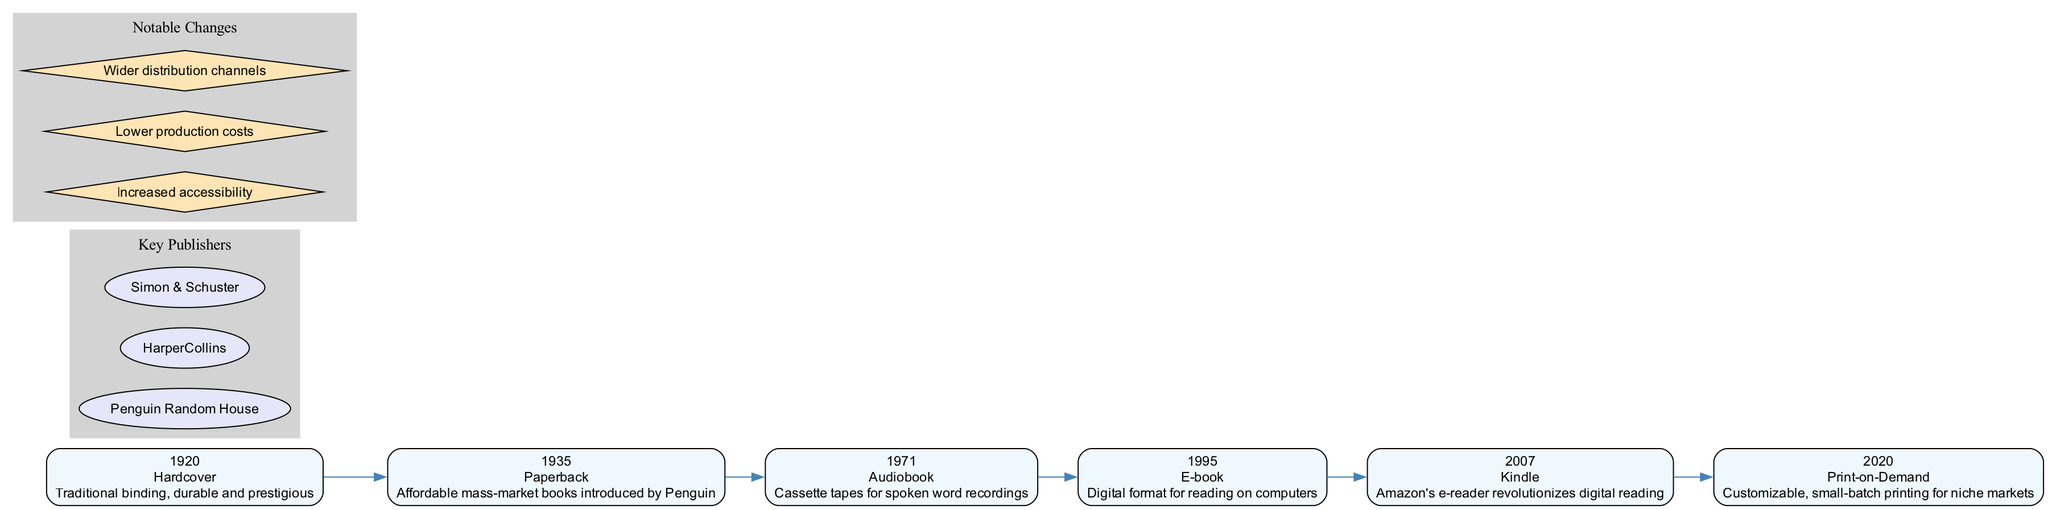What year was the Paperback format introduced? The diagram shows that the Paperback format was introduced in 1935. I can find this by locating the node representing the Paperback format on the timeline.
Answer: 1935 How many book publishing formats are displayed in the timeline? By counting the nodes in the timeline, I see there are six distinct publishing formats: Hardcover, Paperback, Audiobook, E-book, Kindle, and Print-on-Demand.
Answer: 6 What change is noted for the year 2007? The diagram indicates that in 2007, the Kindle format was introduced, which revolutionized digital reading. This information is available in the node corresponding to that year.
Answer: Kindle Which publisher is mentioned as a key publisher? The diagram lists Penguin Random House as one of the key publishers, as indicated within the subgraph containing key publishers.
Answer: Penguin Random House What is a notable change associated with the evolution of book publishing formats? Among the notable changes listed in the diagram, one highlighted change is increased accessibility, which reflects the overall trend of the publishing formats over time.
Answer: Increased accessibility Which format was first introduced in the timeline? By examining the timeline, it is clear that Hardcover was the first format introduced in 1920, as this is the earliest year mentioned in the diagram.
Answer: Hardcover In which year was the Audiobook format introduced? The timeline shows that the Audiobook format was introduced in 1971, as indicated on the corresponding node for that year.
Answer: 1971 What does Print-on-Demand allow publishers to do? The description for Print-on-Demand in 2020 states that it enables customizable, small-batch printing for niche markets. This provides insight into the benefits of this format.
Answer: Customizable, small-batch printing for niche markets 